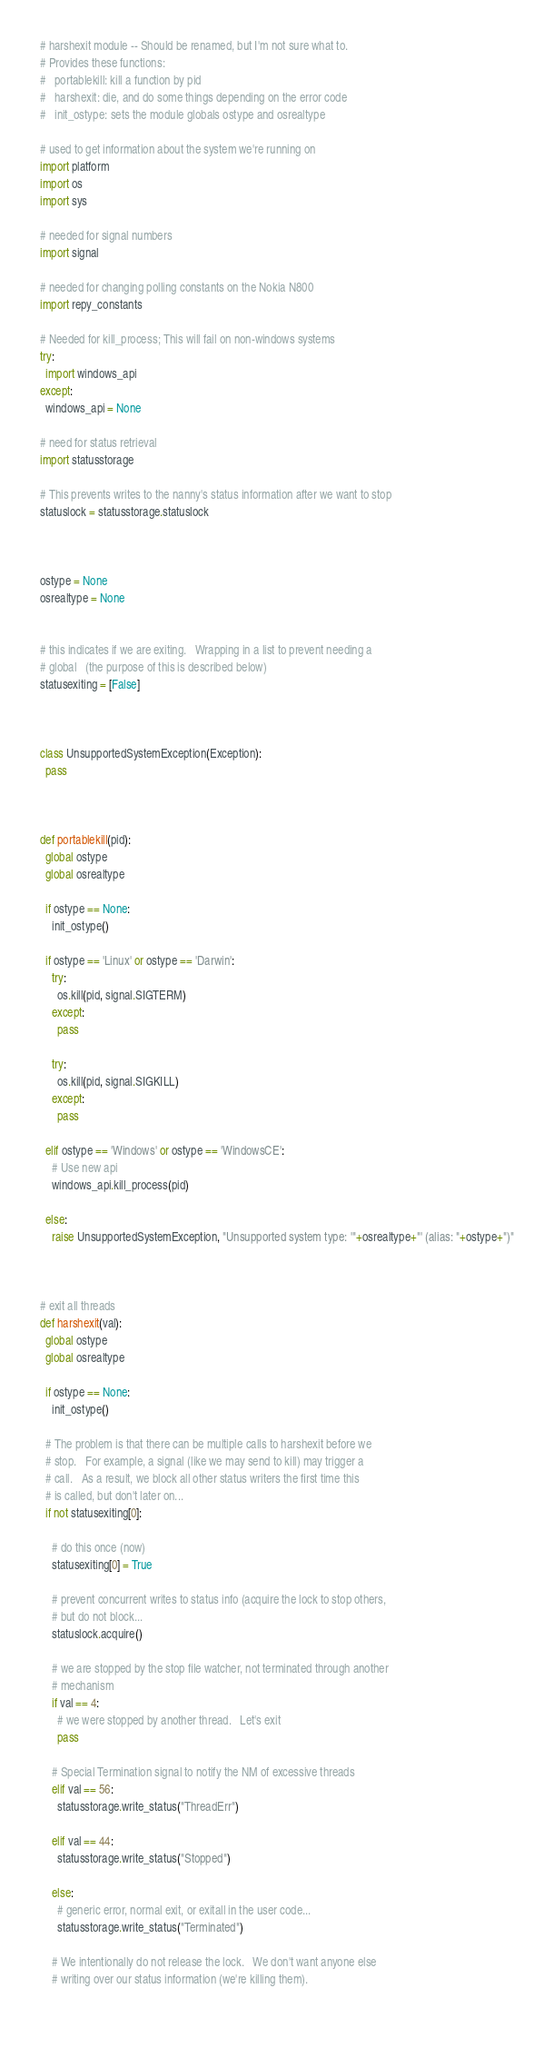<code> <loc_0><loc_0><loc_500><loc_500><_Python_># harshexit module -- Should be renamed, but I'm not sure what to.
# Provides these functions:
#   portablekill: kill a function by pid
#   harshexit: die, and do some things depending on the error code
#   init_ostype: sets the module globals ostype and osrealtype

# used to get information about the system we're running on
import platform
import os
import sys

# needed for signal numbers
import signal

# needed for changing polling constants on the Nokia N800
import repy_constants

# Needed for kill_process; This will fail on non-windows systems
try:
  import windows_api
except:
  windows_api = None

# need for status retrieval
import statusstorage

# This prevents writes to the nanny's status information after we want to stop
statuslock = statusstorage.statuslock



ostype = None
osrealtype = None


# this indicates if we are exiting.   Wrapping in a list to prevent needing a
# global   (the purpose of this is described below)
statusexiting = [False]



class UnsupportedSystemException(Exception):
  pass



def portablekill(pid):
  global ostype
  global osrealtype

  if ostype == None:
    init_ostype()

  if ostype == 'Linux' or ostype == 'Darwin':
    try:
      os.kill(pid, signal.SIGTERM)
    except:
      pass

    try:
      os.kill(pid, signal.SIGKILL)
    except:
      pass

  elif ostype == 'Windows' or ostype == 'WindowsCE':
    # Use new api
    windows_api.kill_process(pid)
    
  else:
    raise UnsupportedSystemException, "Unsupported system type: '"+osrealtype+"' (alias: "+ostype+")"



# exit all threads
def harshexit(val):
  global ostype
  global osrealtype

  if ostype == None:
    init_ostype()

  # The problem is that there can be multiple calls to harshexit before we
  # stop.   For example, a signal (like we may send to kill) may trigger a 
  # call.   As a result, we block all other status writers the first time this
  # is called, but don't later on...
  if not statusexiting[0]:

    # do this once (now)
    statusexiting[0] = True

    # prevent concurrent writes to status info (acquire the lock to stop others,
    # but do not block...
    statuslock.acquire()
  
    # we are stopped by the stop file watcher, not terminated through another 
    # mechanism
    if val == 4:
      # we were stopped by another thread.   Let's exit
      pass
    
    # Special Termination signal to notify the NM of excessive threads
    elif val == 56:
      statusstorage.write_status("ThreadErr")
      
    elif val == 44:
      statusstorage.write_status("Stopped")

    else:
      # generic error, normal exit, or exitall in the user code...
      statusstorage.write_status("Terminated")

    # We intentionally do not release the lock.   We don't want anyone else 
    # writing over our status information (we're killing them).
    
</code> 